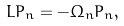<formula> <loc_0><loc_0><loc_500><loc_500>L P _ { n } = - \Omega _ { n } P _ { n } ,</formula> 